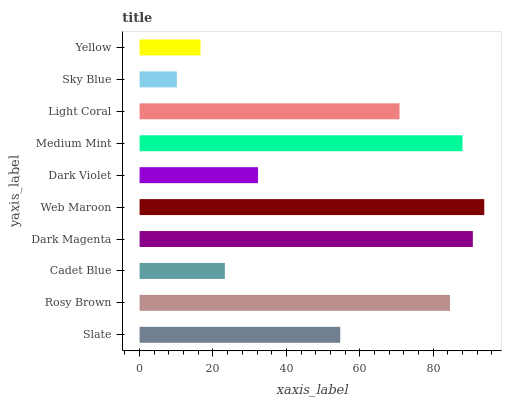Is Sky Blue the minimum?
Answer yes or no. Yes. Is Web Maroon the maximum?
Answer yes or no. Yes. Is Rosy Brown the minimum?
Answer yes or no. No. Is Rosy Brown the maximum?
Answer yes or no. No. Is Rosy Brown greater than Slate?
Answer yes or no. Yes. Is Slate less than Rosy Brown?
Answer yes or no. Yes. Is Slate greater than Rosy Brown?
Answer yes or no. No. Is Rosy Brown less than Slate?
Answer yes or no. No. Is Light Coral the high median?
Answer yes or no. Yes. Is Slate the low median?
Answer yes or no. Yes. Is Slate the high median?
Answer yes or no. No. Is Web Maroon the low median?
Answer yes or no. No. 